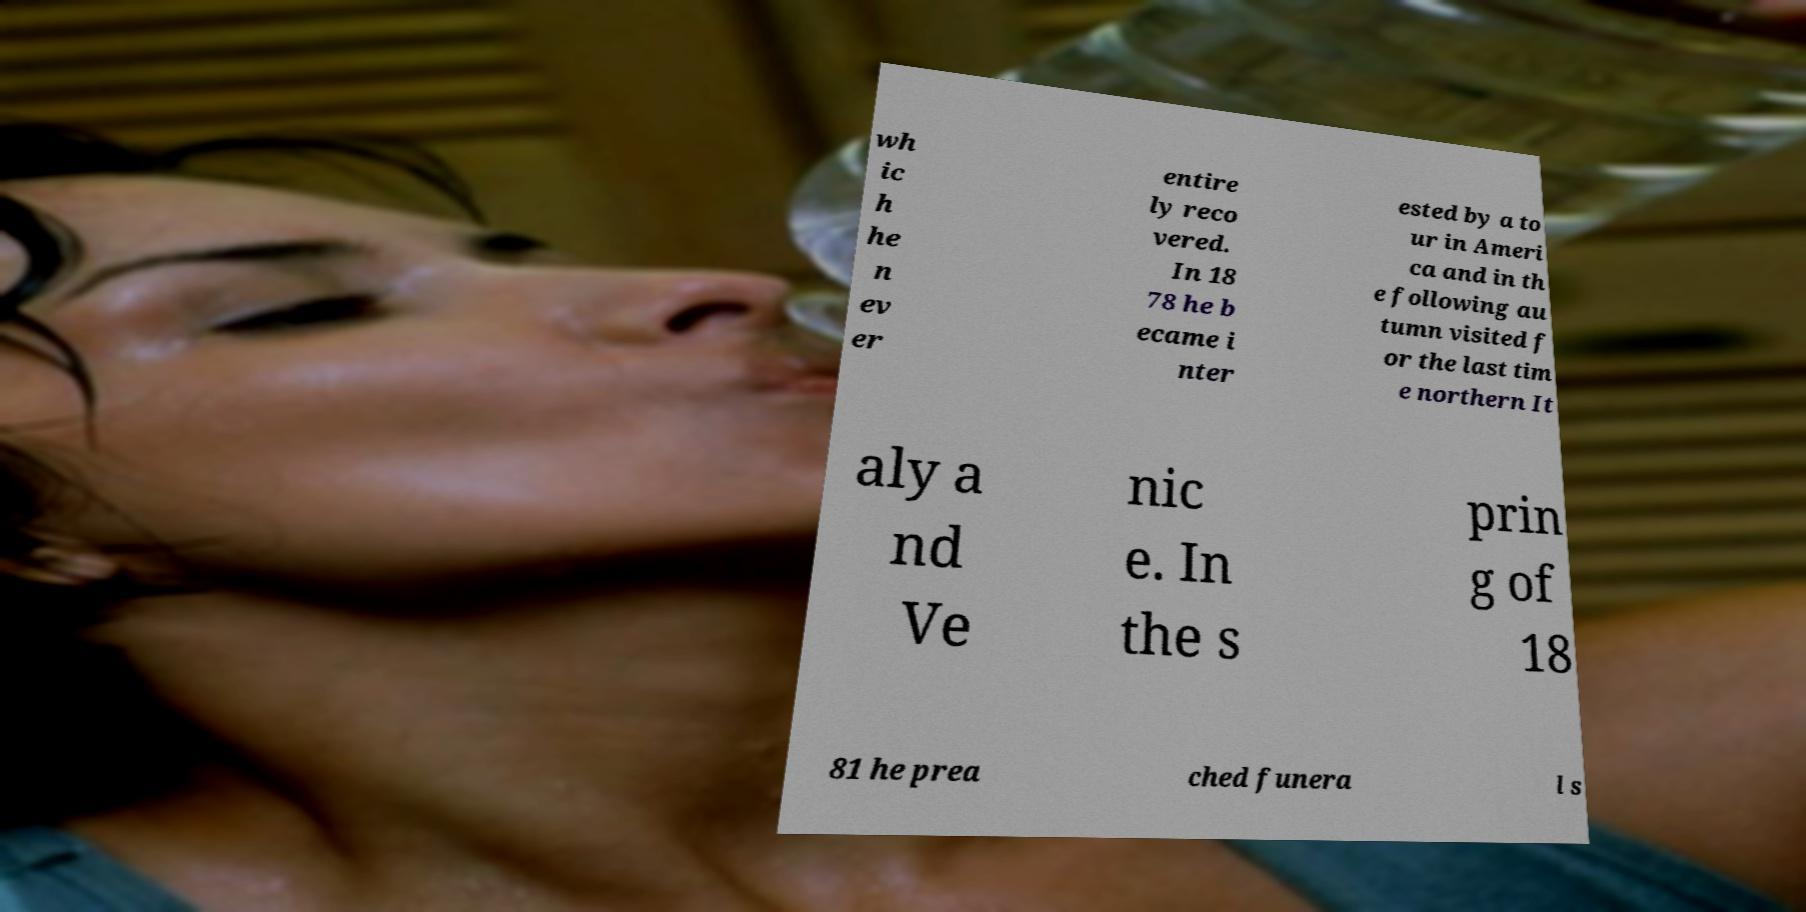Can you read and provide the text displayed in the image?This photo seems to have some interesting text. Can you extract and type it out for me? wh ic h he n ev er entire ly reco vered. In 18 78 he b ecame i nter ested by a to ur in Ameri ca and in th e following au tumn visited f or the last tim e northern It aly a nd Ve nic e. In the s prin g of 18 81 he prea ched funera l s 